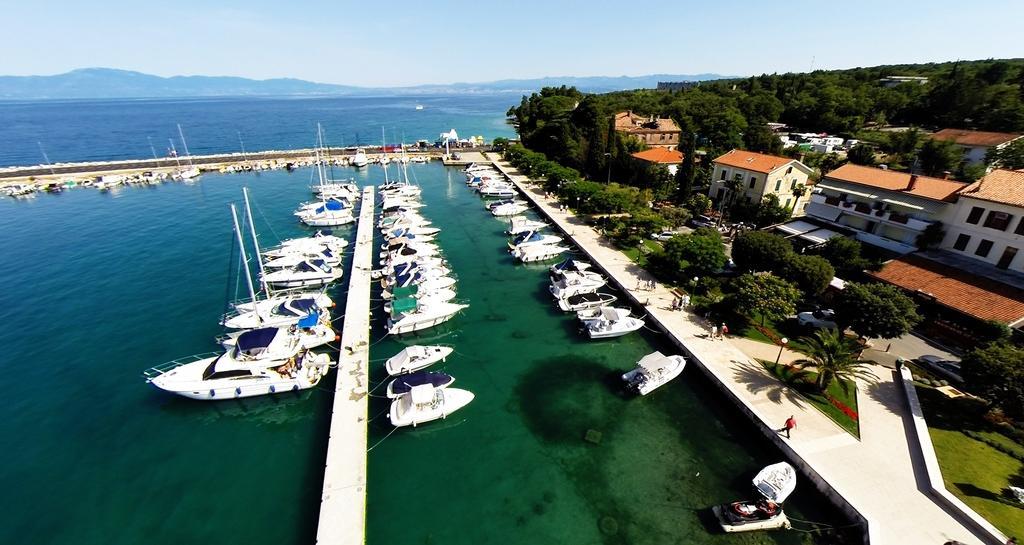Could you give a brief overview of what you see in this image? As we can see in the image there is water, boats, trees, grass, houses and on the top there is sky. 